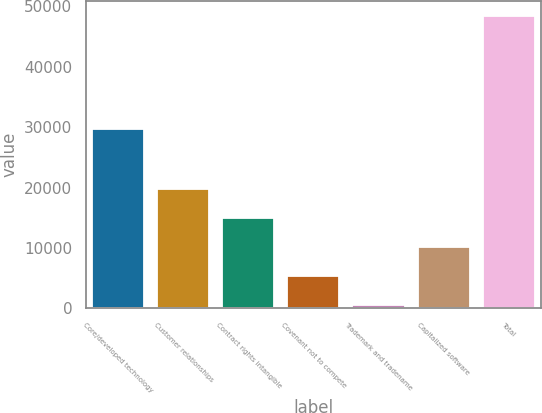Convert chart. <chart><loc_0><loc_0><loc_500><loc_500><bar_chart><fcel>Core/developed technology<fcel>Customer relationships<fcel>Contract rights intangible<fcel>Covenant not to compete<fcel>Trademark and tradename<fcel>Capitalized software<fcel>Total<nl><fcel>29644<fcel>19717.4<fcel>14933.3<fcel>5365.1<fcel>581<fcel>10149.2<fcel>48422<nl></chart> 